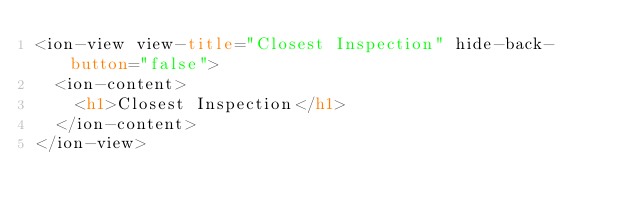<code> <loc_0><loc_0><loc_500><loc_500><_HTML_><ion-view view-title="Closest Inspection" hide-back-button="false">
  <ion-content>
    <h1>Closest Inspection</h1>
  </ion-content>
</ion-view>
</code> 